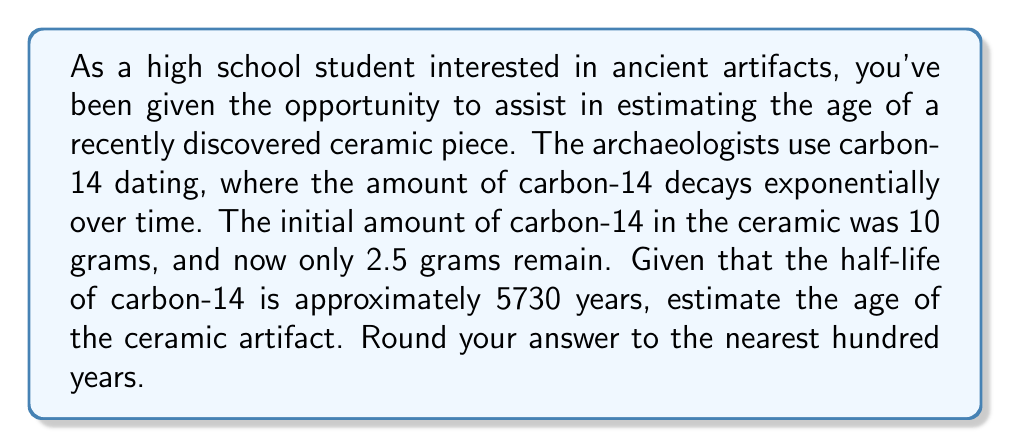Teach me how to tackle this problem. Let's approach this step-by-step using exponential functions and logarithms:

1) The exponential decay function for radioactive materials is:

   $$A(t) = A_0 \cdot e^{-\lambda t}$$

   where $A(t)$ is the amount remaining after time $t$, $A_0$ is the initial amount, and $\lambda$ is the decay constant.

2) We're given:
   $A_0 = 10$ grams (initial amount)
   $A(t) = 2.5$ grams (current amount)
   Half-life = 5730 years

3) First, we need to find $\lambda$. Using the half-life formula:

   $$\frac{1}{2} = e^{-\lambda \cdot 5730}$$

4) Taking natural log of both sides:

   $$\ln(\frac{1}{2}) = -5730\lambda$$

5) Solving for $\lambda$:

   $$\lambda = \frac{\ln(2)}{5730} \approx 0.000121$$

6) Now we can use the original decay equation:

   $$2.5 = 10 \cdot e^{-0.000121t}$$

7) Dividing both sides by 10:

   $$0.25 = e^{-0.000121t}$$

8) Taking natural log of both sides:

   $$\ln(0.25) = -0.000121t$$

9) Solving for $t$:

   $$t = \frac{\ln(0.25)}{-0.000121} \approx 11460.75$$

10) Rounding to the nearest hundred years:

    $$t \approx 11500 \text{ years}$$
Answer: 11500 years 